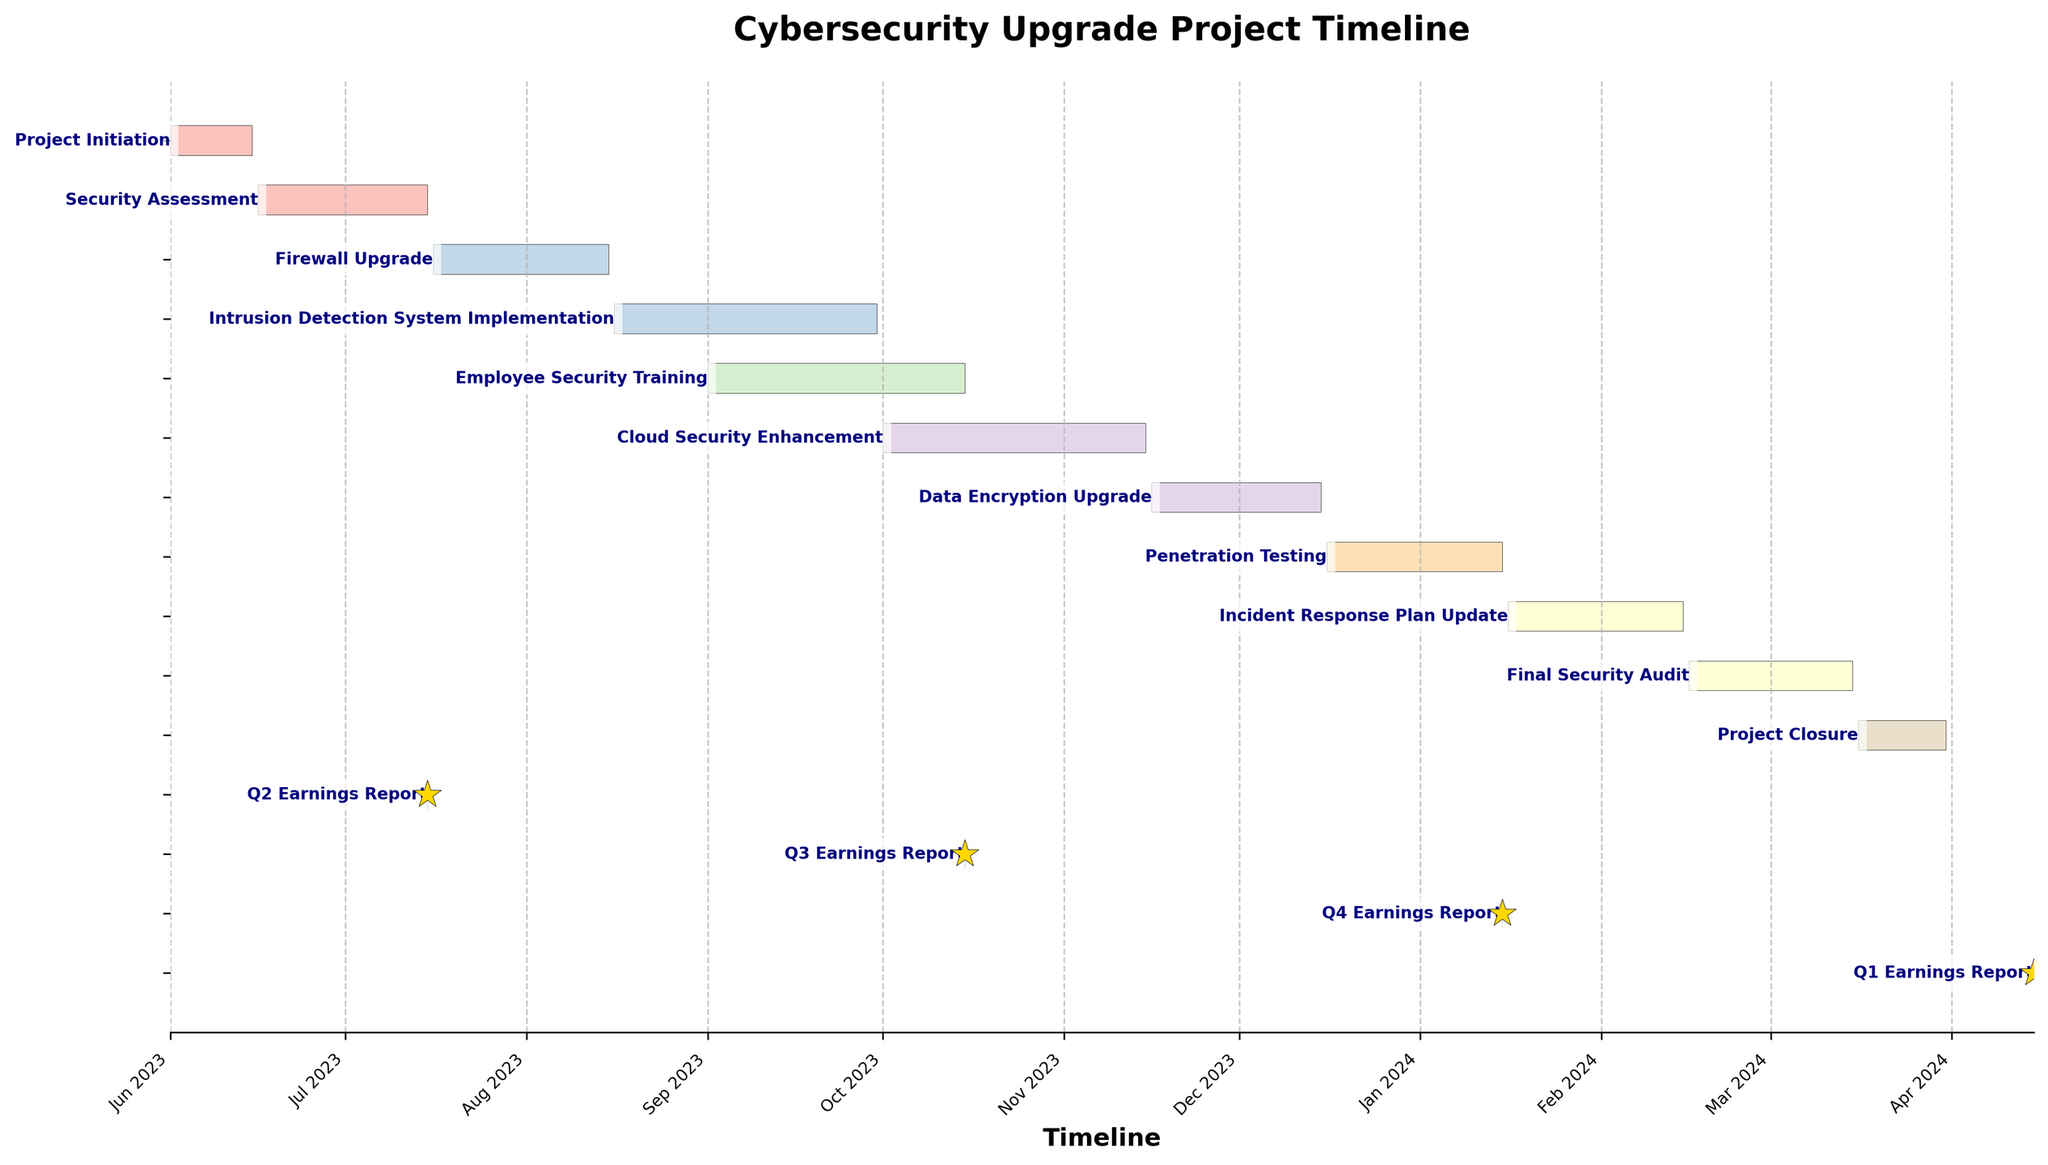What is the title of the Gantt Chart? The title of the Gantt Chart specifies the overall subject of the visualization. Here, the title is prominently displayed at the top.
Answer: Cybersecurity Upgrade Project Timeline Which task has the longest duration in the project? First, identify the duration of each task. Comparing all task durations, the task with the longest duration is the Cloud Security Enhancement, which spans 45 days.
Answer: Cloud Security Enhancement How many tasks have a duration of exactly 30 days? Check the duration listed for each task. The tasks Firewall Upgrade, Penetration Testing, and Incident Response Plan Update each have a duration of 30 days.
Answer: 3 What are the start and end dates of the Final Security Audit? Locate the Final Security Audit in the chart and read its respective start and end dates. These dates are marked beside the task bar.
Answer: Start: 2024-02-16, End: 2024-03-15 How does the timeline of the Employee Security Training compare to the Cloud Security Enhancement in terms of start and end dates? Employee Security Training starts on 2023-09-01 and ends on 2023-10-15, whereas Cloud Security Enhancement starts on 2023-10-01 and ends on 2023-11-15. Both overlap but Cloud Security Enhancement starts just before Employee Security Training finishes.
Answer: Employee Security Training: 2023-09-01 to 2023-10-15, Cloud Security Enhancement: 2023-10-01 to 2023-11-15 How many earnings reports are included in the Gantt Chart, and when is the final report scheduled? The number of data points marked as earnings reports in the chart can be identified by counting the markers. There are four earnings report dates, with the final report scheduled on 2024-04-15.
Answer: 4, 2024-04-15 What is the total duration from the start of the Project Initiation to the end of the Project Closure? The Project Initiation starts on 2023-06-01 and Project Closure ends on 2024-03-31. Calculate the total duration by finding the interval between these two dates. This duration is approximately 305 days.
Answer: 305 days Which two tasks overlap the most in terms of their timelines? To determine which tasks overlap the most, visually inspect the chart for overlapping bars with the longest shared duration. The most overlap occurs between the Employee Security Training and Cloud Security Enhancement tasks.
Answer: Employee Security Training and Cloud Security Enhancement 